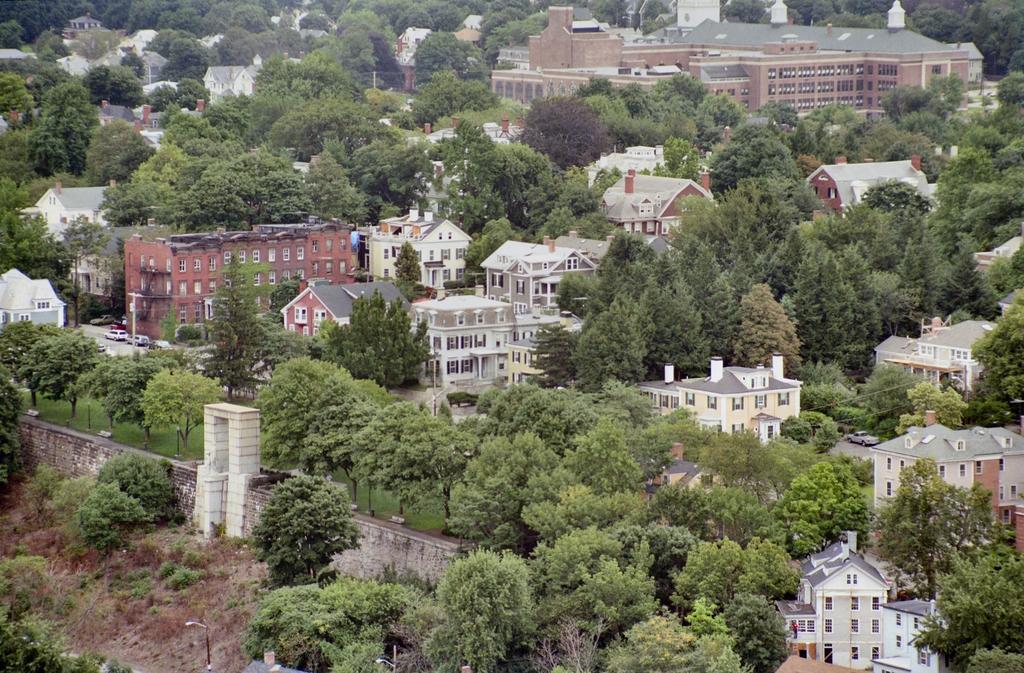Can you describe this image briefly? In the image in the center we can see buildings,windows,trees,grass,pole,plants etc. 